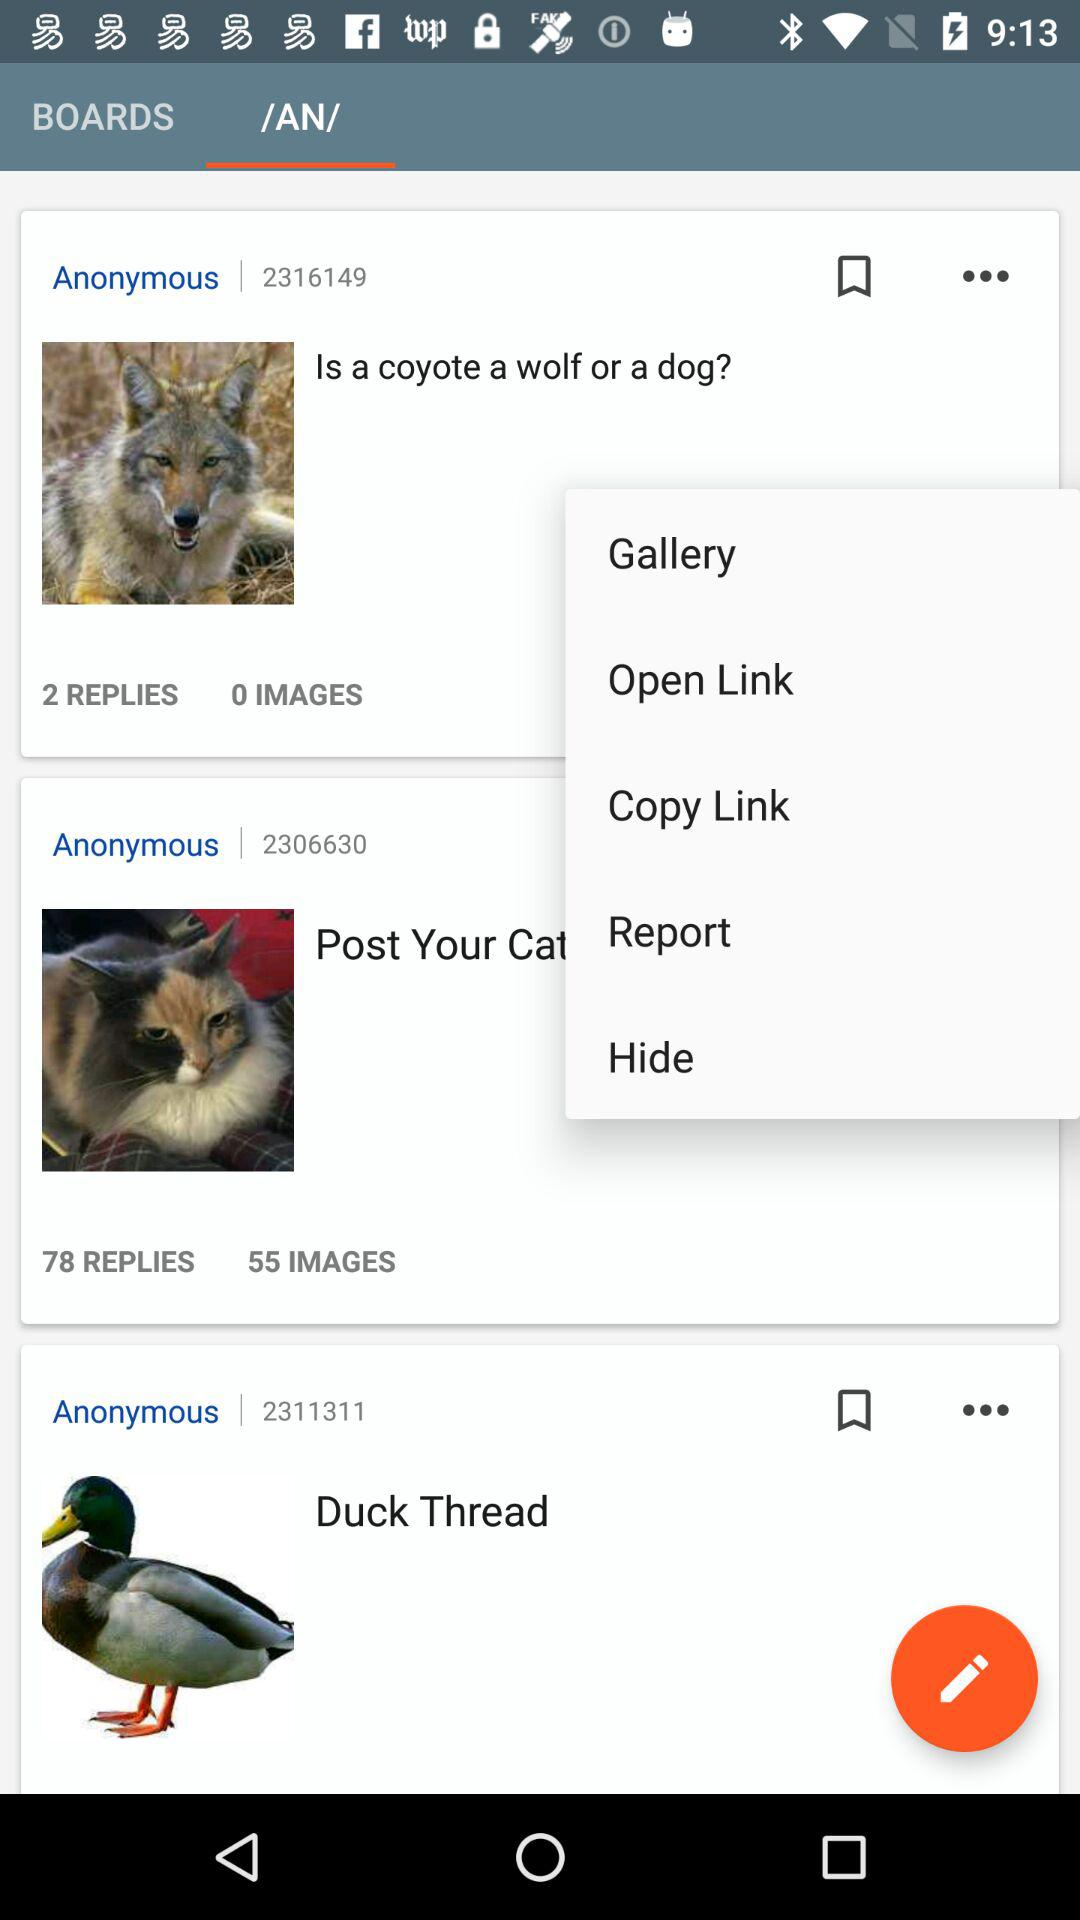How many replies are there to the question 'Is a coyote a wolf or a dog?'
Answer the question using a single word or phrase. 2 